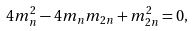<formula> <loc_0><loc_0><loc_500><loc_500>4 m _ { n } ^ { 2 } - 4 m _ { n } m _ { 2 n } + m _ { 2 n } ^ { 2 } = 0 ,</formula> 